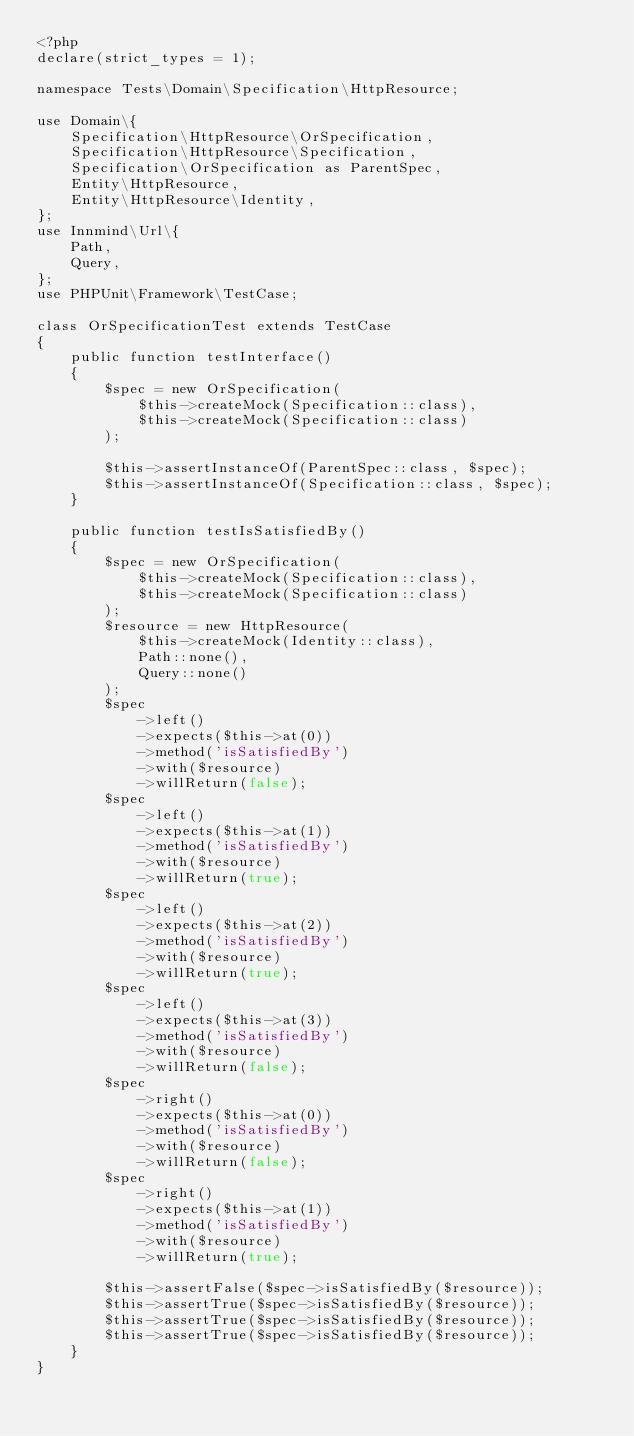<code> <loc_0><loc_0><loc_500><loc_500><_PHP_><?php
declare(strict_types = 1);

namespace Tests\Domain\Specification\HttpResource;

use Domain\{
    Specification\HttpResource\OrSpecification,
    Specification\HttpResource\Specification,
    Specification\OrSpecification as ParentSpec,
    Entity\HttpResource,
    Entity\HttpResource\Identity,
};
use Innmind\Url\{
    Path,
    Query,
};
use PHPUnit\Framework\TestCase;

class OrSpecificationTest extends TestCase
{
    public function testInterface()
    {
        $spec = new OrSpecification(
            $this->createMock(Specification::class),
            $this->createMock(Specification::class)
        );

        $this->assertInstanceOf(ParentSpec::class, $spec);
        $this->assertInstanceOf(Specification::class, $spec);
    }

    public function testIsSatisfiedBy()
    {
        $spec = new OrSpecification(
            $this->createMock(Specification::class),
            $this->createMock(Specification::class)
        );
        $resource = new HttpResource(
            $this->createMock(Identity::class),
            Path::none(),
            Query::none()
        );
        $spec
            ->left()
            ->expects($this->at(0))
            ->method('isSatisfiedBy')
            ->with($resource)
            ->willReturn(false);
        $spec
            ->left()
            ->expects($this->at(1))
            ->method('isSatisfiedBy')
            ->with($resource)
            ->willReturn(true);
        $spec
            ->left()
            ->expects($this->at(2))
            ->method('isSatisfiedBy')
            ->with($resource)
            ->willReturn(true);
        $spec
            ->left()
            ->expects($this->at(3))
            ->method('isSatisfiedBy')
            ->with($resource)
            ->willReturn(false);
        $spec
            ->right()
            ->expects($this->at(0))
            ->method('isSatisfiedBy')
            ->with($resource)
            ->willReturn(false);
        $spec
            ->right()
            ->expects($this->at(1))
            ->method('isSatisfiedBy')
            ->with($resource)
            ->willReturn(true);

        $this->assertFalse($spec->isSatisfiedBy($resource));
        $this->assertTrue($spec->isSatisfiedBy($resource));
        $this->assertTrue($spec->isSatisfiedBy($resource));
        $this->assertTrue($spec->isSatisfiedBy($resource));
    }
}
</code> 